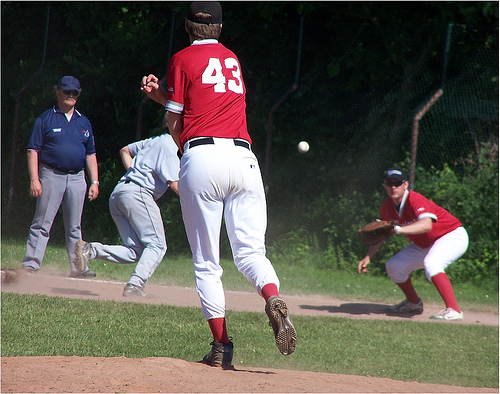Please transcribe the text information in this image. 43 